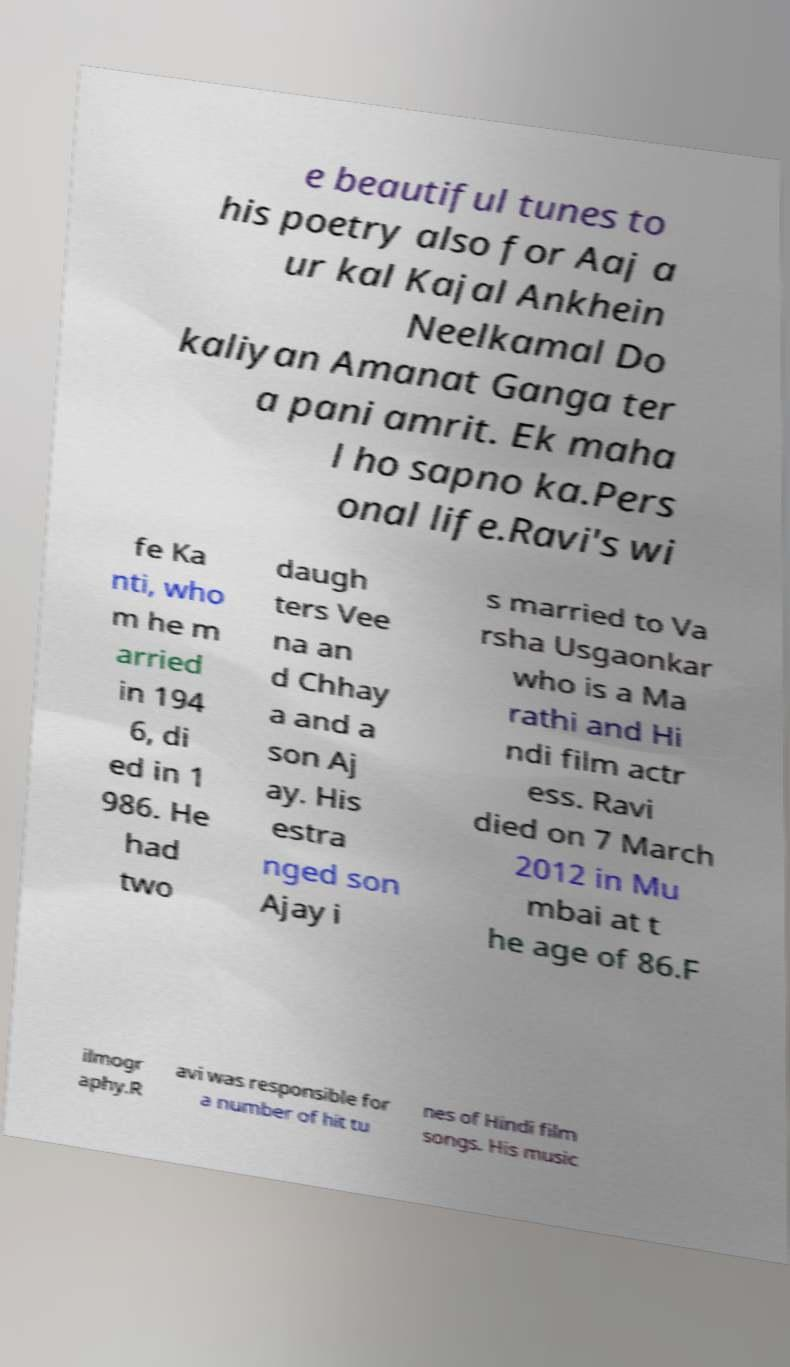I need the written content from this picture converted into text. Can you do that? e beautiful tunes to his poetry also for Aaj a ur kal Kajal Ankhein Neelkamal Do kaliyan Amanat Ganga ter a pani amrit. Ek maha l ho sapno ka.Pers onal life.Ravi's wi fe Ka nti, who m he m arried in 194 6, di ed in 1 986. He had two daugh ters Vee na an d Chhay a and a son Aj ay. His estra nged son Ajay i s married to Va rsha Usgaonkar who is a Ma rathi and Hi ndi film actr ess. Ravi died on 7 March 2012 in Mu mbai at t he age of 86.F ilmogr aphy.R avi was responsible for a number of hit tu nes of Hindi film songs. His music 